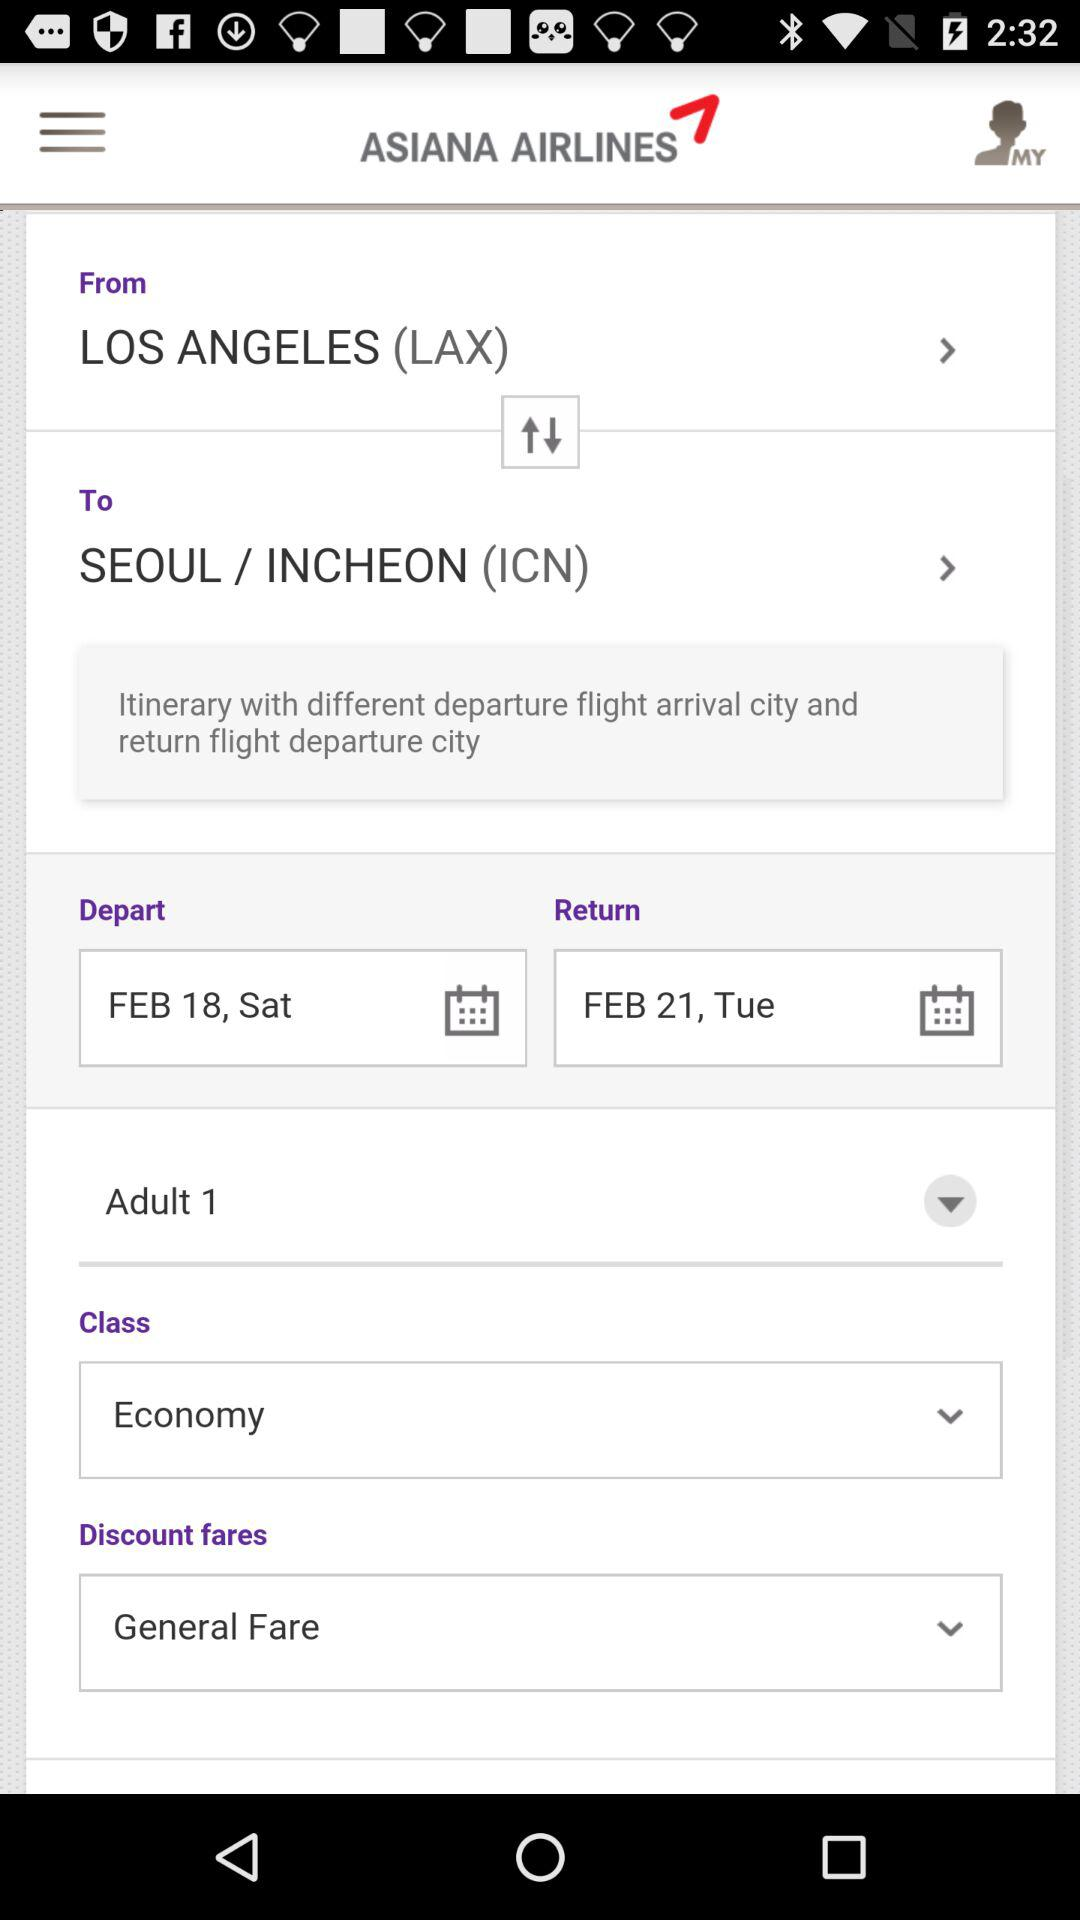What is the "Depart" date? The date is Saturday, February 18. 